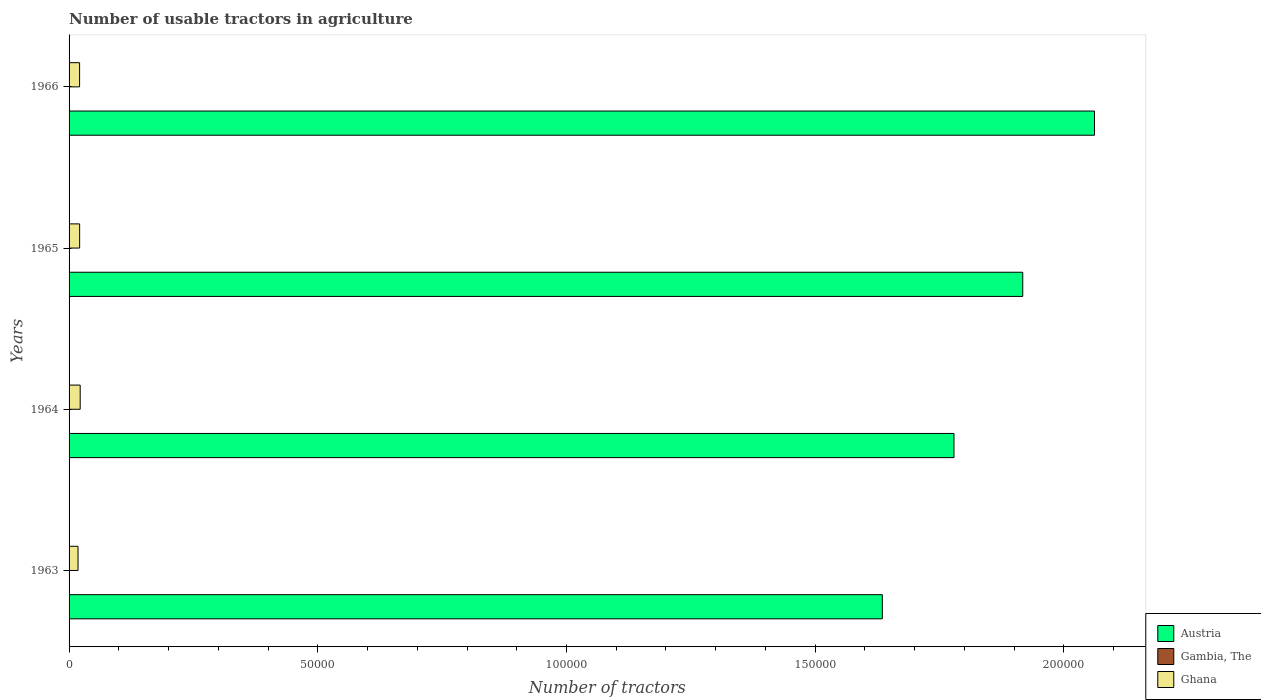How many different coloured bars are there?
Offer a terse response. 3. Are the number of bars per tick equal to the number of legend labels?
Provide a succinct answer. Yes. How many bars are there on the 3rd tick from the bottom?
Ensure brevity in your answer.  3. What is the label of the 2nd group of bars from the top?
Your answer should be compact. 1965. In how many cases, is the number of bars for a given year not equal to the number of legend labels?
Keep it short and to the point. 0. What is the number of usable tractors in agriculture in Gambia, The in 1964?
Your answer should be compact. 43. Across all years, what is the maximum number of usable tractors in agriculture in Ghana?
Offer a very short reply. 2234. In which year was the number of usable tractors in agriculture in Gambia, The maximum?
Offer a terse response. 1966. In which year was the number of usable tractors in agriculture in Gambia, The minimum?
Keep it short and to the point. 1963. What is the total number of usable tractors in agriculture in Ghana in the graph?
Your response must be concise. 8274. What is the difference between the number of usable tractors in agriculture in Austria in 1964 and the number of usable tractors in agriculture in Gambia, The in 1965?
Offer a very short reply. 1.78e+05. What is the average number of usable tractors in agriculture in Austria per year?
Give a very brief answer. 1.85e+05. In the year 1965, what is the difference between the number of usable tractors in agriculture in Austria and number of usable tractors in agriculture in Ghana?
Your answer should be very brief. 1.90e+05. What is the ratio of the number of usable tractors in agriculture in Austria in 1965 to that in 1966?
Make the answer very short. 0.93. What is the difference between the highest and the second highest number of usable tractors in agriculture in Gambia, The?
Provide a short and direct response. 1. What is the difference between the highest and the lowest number of usable tractors in agriculture in Austria?
Give a very brief answer. 4.27e+04. In how many years, is the number of usable tractors in agriculture in Ghana greater than the average number of usable tractors in agriculture in Ghana taken over all years?
Provide a short and direct response. 3. What does the 3rd bar from the top in 1963 represents?
Your response must be concise. Austria. What does the 1st bar from the bottom in 1966 represents?
Offer a very short reply. Austria. What is the difference between two consecutive major ticks on the X-axis?
Your answer should be very brief. 5.00e+04. Are the values on the major ticks of X-axis written in scientific E-notation?
Provide a succinct answer. No. Where does the legend appear in the graph?
Provide a short and direct response. Bottom right. How many legend labels are there?
Your answer should be compact. 3. How are the legend labels stacked?
Your answer should be compact. Vertical. What is the title of the graph?
Give a very brief answer. Number of usable tractors in agriculture. Does "United Kingdom" appear as one of the legend labels in the graph?
Your response must be concise. No. What is the label or title of the X-axis?
Offer a terse response. Number of tractors. What is the label or title of the Y-axis?
Make the answer very short. Years. What is the Number of tractors in Austria in 1963?
Your response must be concise. 1.63e+05. What is the Number of tractors in Ghana in 1963?
Offer a terse response. 1800. What is the Number of tractors in Austria in 1964?
Provide a succinct answer. 1.78e+05. What is the Number of tractors in Ghana in 1964?
Offer a very short reply. 2234. What is the Number of tractors in Austria in 1965?
Your response must be concise. 1.92e+05. What is the Number of tractors of Ghana in 1965?
Your response must be concise. 2124. What is the Number of tractors in Austria in 1966?
Your response must be concise. 2.06e+05. What is the Number of tractors of Gambia, The in 1966?
Provide a succinct answer. 44. What is the Number of tractors in Ghana in 1966?
Offer a very short reply. 2116. Across all years, what is the maximum Number of tractors of Austria?
Your response must be concise. 2.06e+05. Across all years, what is the maximum Number of tractors in Gambia, The?
Ensure brevity in your answer.  44. Across all years, what is the maximum Number of tractors of Ghana?
Give a very brief answer. 2234. Across all years, what is the minimum Number of tractors in Austria?
Your answer should be very brief. 1.63e+05. Across all years, what is the minimum Number of tractors in Gambia, The?
Offer a terse response. 43. Across all years, what is the minimum Number of tractors in Ghana?
Offer a terse response. 1800. What is the total Number of tractors in Austria in the graph?
Offer a terse response. 7.39e+05. What is the total Number of tractors of Gambia, The in the graph?
Keep it short and to the point. 173. What is the total Number of tractors in Ghana in the graph?
Your answer should be very brief. 8274. What is the difference between the Number of tractors of Austria in 1963 and that in 1964?
Ensure brevity in your answer.  -1.44e+04. What is the difference between the Number of tractors in Ghana in 1963 and that in 1964?
Keep it short and to the point. -434. What is the difference between the Number of tractors of Austria in 1963 and that in 1965?
Offer a terse response. -2.82e+04. What is the difference between the Number of tractors of Gambia, The in 1963 and that in 1965?
Provide a short and direct response. 0. What is the difference between the Number of tractors of Ghana in 1963 and that in 1965?
Offer a very short reply. -324. What is the difference between the Number of tractors of Austria in 1963 and that in 1966?
Give a very brief answer. -4.27e+04. What is the difference between the Number of tractors in Gambia, The in 1963 and that in 1966?
Make the answer very short. -1. What is the difference between the Number of tractors in Ghana in 1963 and that in 1966?
Offer a terse response. -316. What is the difference between the Number of tractors in Austria in 1964 and that in 1965?
Provide a short and direct response. -1.38e+04. What is the difference between the Number of tractors of Gambia, The in 1964 and that in 1965?
Ensure brevity in your answer.  0. What is the difference between the Number of tractors of Ghana in 1964 and that in 1965?
Give a very brief answer. 110. What is the difference between the Number of tractors in Austria in 1964 and that in 1966?
Ensure brevity in your answer.  -2.83e+04. What is the difference between the Number of tractors in Ghana in 1964 and that in 1966?
Your answer should be compact. 118. What is the difference between the Number of tractors in Austria in 1965 and that in 1966?
Provide a succinct answer. -1.44e+04. What is the difference between the Number of tractors of Gambia, The in 1965 and that in 1966?
Offer a very short reply. -1. What is the difference between the Number of tractors of Austria in 1963 and the Number of tractors of Gambia, The in 1964?
Give a very brief answer. 1.63e+05. What is the difference between the Number of tractors in Austria in 1963 and the Number of tractors in Ghana in 1964?
Your answer should be very brief. 1.61e+05. What is the difference between the Number of tractors of Gambia, The in 1963 and the Number of tractors of Ghana in 1964?
Give a very brief answer. -2191. What is the difference between the Number of tractors in Austria in 1963 and the Number of tractors in Gambia, The in 1965?
Provide a short and direct response. 1.63e+05. What is the difference between the Number of tractors in Austria in 1963 and the Number of tractors in Ghana in 1965?
Your answer should be very brief. 1.61e+05. What is the difference between the Number of tractors of Gambia, The in 1963 and the Number of tractors of Ghana in 1965?
Your answer should be compact. -2081. What is the difference between the Number of tractors in Austria in 1963 and the Number of tractors in Gambia, The in 1966?
Keep it short and to the point. 1.63e+05. What is the difference between the Number of tractors of Austria in 1963 and the Number of tractors of Ghana in 1966?
Give a very brief answer. 1.61e+05. What is the difference between the Number of tractors in Gambia, The in 1963 and the Number of tractors in Ghana in 1966?
Keep it short and to the point. -2073. What is the difference between the Number of tractors of Austria in 1964 and the Number of tractors of Gambia, The in 1965?
Provide a short and direct response. 1.78e+05. What is the difference between the Number of tractors in Austria in 1964 and the Number of tractors in Ghana in 1965?
Offer a very short reply. 1.76e+05. What is the difference between the Number of tractors of Gambia, The in 1964 and the Number of tractors of Ghana in 1965?
Your response must be concise. -2081. What is the difference between the Number of tractors of Austria in 1964 and the Number of tractors of Gambia, The in 1966?
Your response must be concise. 1.78e+05. What is the difference between the Number of tractors of Austria in 1964 and the Number of tractors of Ghana in 1966?
Keep it short and to the point. 1.76e+05. What is the difference between the Number of tractors of Gambia, The in 1964 and the Number of tractors of Ghana in 1966?
Offer a terse response. -2073. What is the difference between the Number of tractors of Austria in 1965 and the Number of tractors of Gambia, The in 1966?
Provide a short and direct response. 1.92e+05. What is the difference between the Number of tractors of Austria in 1965 and the Number of tractors of Ghana in 1966?
Provide a short and direct response. 1.90e+05. What is the difference between the Number of tractors in Gambia, The in 1965 and the Number of tractors in Ghana in 1966?
Give a very brief answer. -2073. What is the average Number of tractors of Austria per year?
Offer a very short reply. 1.85e+05. What is the average Number of tractors in Gambia, The per year?
Keep it short and to the point. 43.25. What is the average Number of tractors of Ghana per year?
Your answer should be compact. 2068.5. In the year 1963, what is the difference between the Number of tractors of Austria and Number of tractors of Gambia, The?
Your response must be concise. 1.63e+05. In the year 1963, what is the difference between the Number of tractors in Austria and Number of tractors in Ghana?
Offer a terse response. 1.62e+05. In the year 1963, what is the difference between the Number of tractors in Gambia, The and Number of tractors in Ghana?
Provide a succinct answer. -1757. In the year 1964, what is the difference between the Number of tractors in Austria and Number of tractors in Gambia, The?
Keep it short and to the point. 1.78e+05. In the year 1964, what is the difference between the Number of tractors in Austria and Number of tractors in Ghana?
Your answer should be compact. 1.76e+05. In the year 1964, what is the difference between the Number of tractors of Gambia, The and Number of tractors of Ghana?
Make the answer very short. -2191. In the year 1965, what is the difference between the Number of tractors of Austria and Number of tractors of Gambia, The?
Your response must be concise. 1.92e+05. In the year 1965, what is the difference between the Number of tractors in Austria and Number of tractors in Ghana?
Your response must be concise. 1.90e+05. In the year 1965, what is the difference between the Number of tractors of Gambia, The and Number of tractors of Ghana?
Your answer should be compact. -2081. In the year 1966, what is the difference between the Number of tractors in Austria and Number of tractors in Gambia, The?
Your answer should be very brief. 2.06e+05. In the year 1966, what is the difference between the Number of tractors in Austria and Number of tractors in Ghana?
Keep it short and to the point. 2.04e+05. In the year 1966, what is the difference between the Number of tractors in Gambia, The and Number of tractors in Ghana?
Your response must be concise. -2072. What is the ratio of the Number of tractors in Austria in 1963 to that in 1964?
Keep it short and to the point. 0.92. What is the ratio of the Number of tractors of Gambia, The in 1963 to that in 1964?
Make the answer very short. 1. What is the ratio of the Number of tractors of Ghana in 1963 to that in 1964?
Your answer should be very brief. 0.81. What is the ratio of the Number of tractors of Austria in 1963 to that in 1965?
Your answer should be very brief. 0.85. What is the ratio of the Number of tractors of Gambia, The in 1963 to that in 1965?
Give a very brief answer. 1. What is the ratio of the Number of tractors in Ghana in 1963 to that in 1965?
Your answer should be very brief. 0.85. What is the ratio of the Number of tractors in Austria in 1963 to that in 1966?
Offer a very short reply. 0.79. What is the ratio of the Number of tractors in Gambia, The in 1963 to that in 1966?
Make the answer very short. 0.98. What is the ratio of the Number of tractors of Ghana in 1963 to that in 1966?
Make the answer very short. 0.85. What is the ratio of the Number of tractors of Austria in 1964 to that in 1965?
Your response must be concise. 0.93. What is the ratio of the Number of tractors in Gambia, The in 1964 to that in 1965?
Give a very brief answer. 1. What is the ratio of the Number of tractors in Ghana in 1964 to that in 1965?
Ensure brevity in your answer.  1.05. What is the ratio of the Number of tractors in Austria in 1964 to that in 1966?
Offer a very short reply. 0.86. What is the ratio of the Number of tractors in Gambia, The in 1964 to that in 1966?
Provide a succinct answer. 0.98. What is the ratio of the Number of tractors in Ghana in 1964 to that in 1966?
Offer a terse response. 1.06. What is the ratio of the Number of tractors in Austria in 1965 to that in 1966?
Keep it short and to the point. 0.93. What is the ratio of the Number of tractors of Gambia, The in 1965 to that in 1966?
Keep it short and to the point. 0.98. What is the ratio of the Number of tractors in Ghana in 1965 to that in 1966?
Your answer should be compact. 1. What is the difference between the highest and the second highest Number of tractors in Austria?
Provide a short and direct response. 1.44e+04. What is the difference between the highest and the second highest Number of tractors of Ghana?
Provide a short and direct response. 110. What is the difference between the highest and the lowest Number of tractors in Austria?
Your answer should be compact. 4.27e+04. What is the difference between the highest and the lowest Number of tractors in Gambia, The?
Your answer should be compact. 1. What is the difference between the highest and the lowest Number of tractors in Ghana?
Your answer should be very brief. 434. 